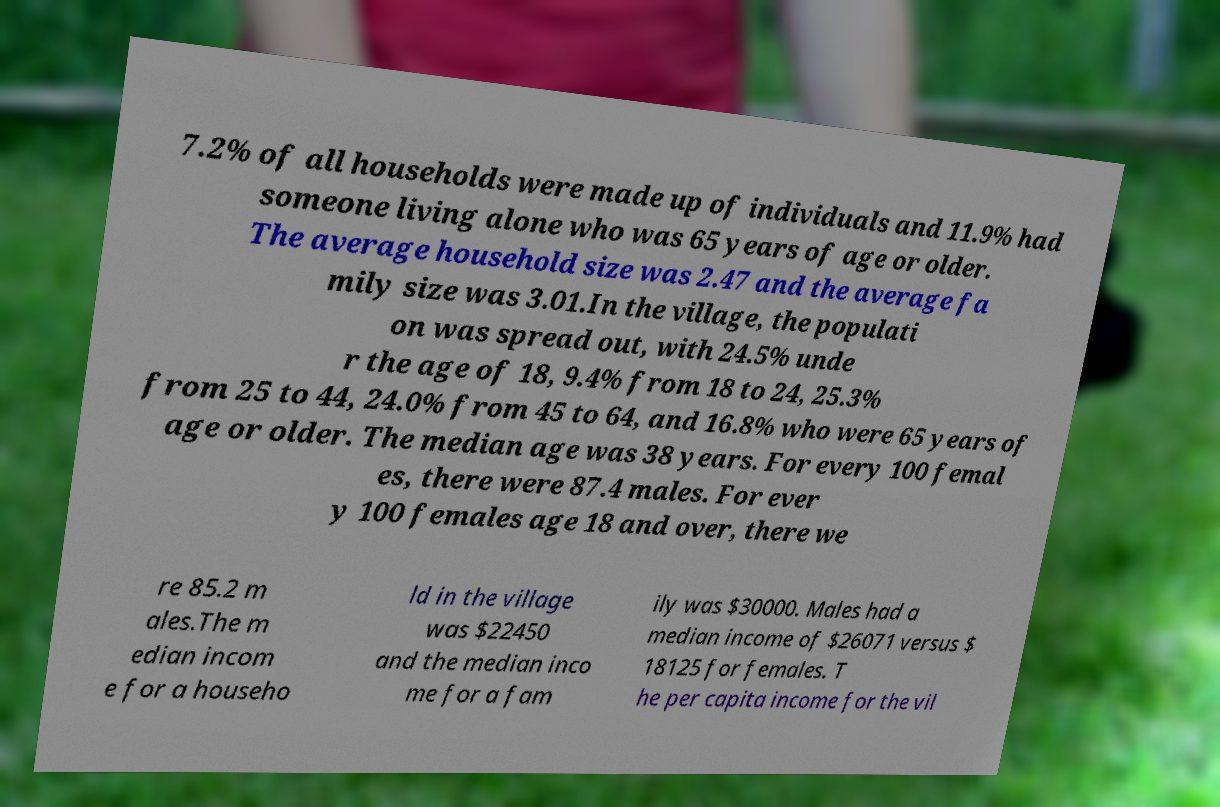Can you read and provide the text displayed in the image?This photo seems to have some interesting text. Can you extract and type it out for me? 7.2% of all households were made up of individuals and 11.9% had someone living alone who was 65 years of age or older. The average household size was 2.47 and the average fa mily size was 3.01.In the village, the populati on was spread out, with 24.5% unde r the age of 18, 9.4% from 18 to 24, 25.3% from 25 to 44, 24.0% from 45 to 64, and 16.8% who were 65 years of age or older. The median age was 38 years. For every 100 femal es, there were 87.4 males. For ever y 100 females age 18 and over, there we re 85.2 m ales.The m edian incom e for a househo ld in the village was $22450 and the median inco me for a fam ily was $30000. Males had a median income of $26071 versus $ 18125 for females. T he per capita income for the vil 